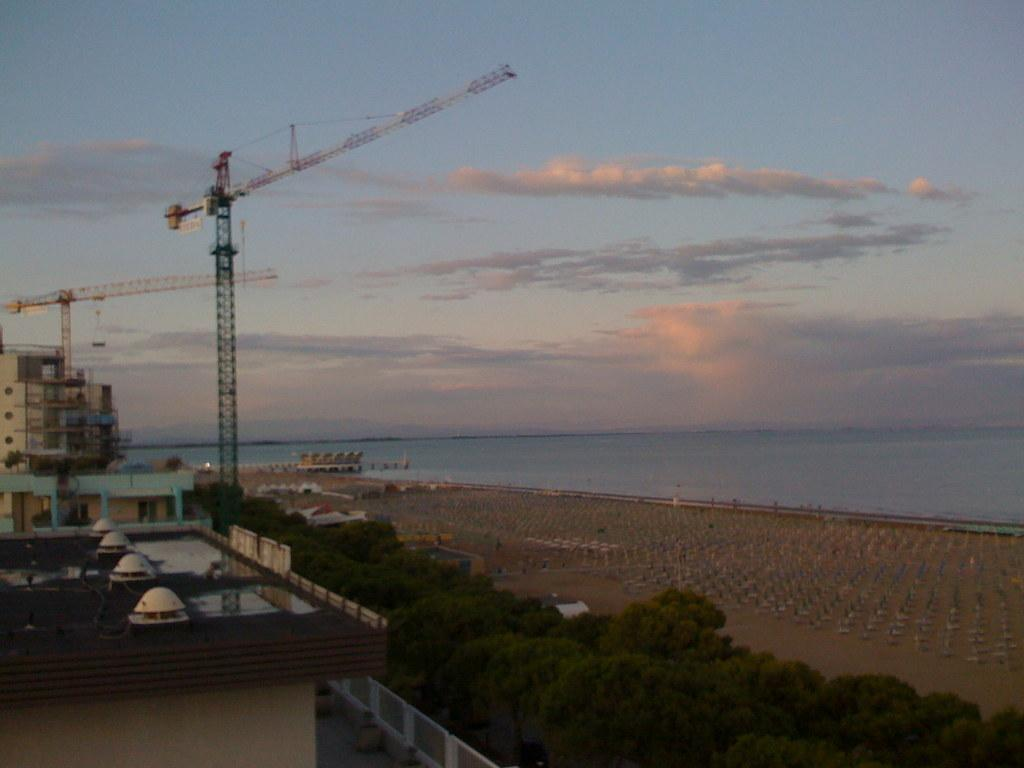What type of natural feature is present in the image? There is a river in the image. What can be found around the river? There are plants, trees, houses, and buildings around the river. Can you describe the vegetation around the river? There are plants and trees around the river. What type of structures are near the river? There are houses and buildings around the river. Are there any other unspecified things around the river? Yes, there are other unspecified things around the river. What type of beggar can be seen using the apparatus near the river in the image? There is no beggar or apparatus present in the image. Can you describe the boat that is floating on the river in the image? There is no boat present in the image; it only features a river, plants, trees, houses, buildings, and other unspecified things. 